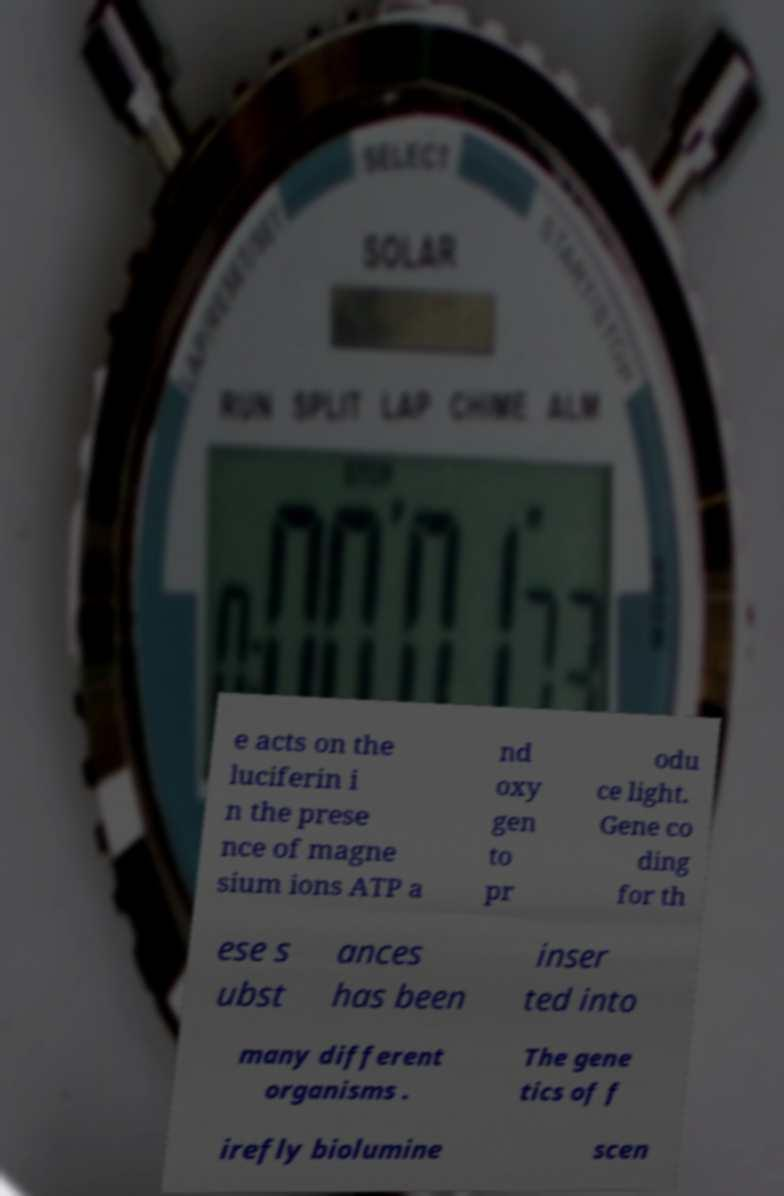Could you extract and type out the text from this image? e acts on the luciferin i n the prese nce of magne sium ions ATP a nd oxy gen to pr odu ce light. Gene co ding for th ese s ubst ances has been inser ted into many different organisms . The gene tics of f irefly biolumine scen 